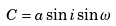<formula> <loc_0><loc_0><loc_500><loc_500>C = a \sin i \sin \omega</formula> 